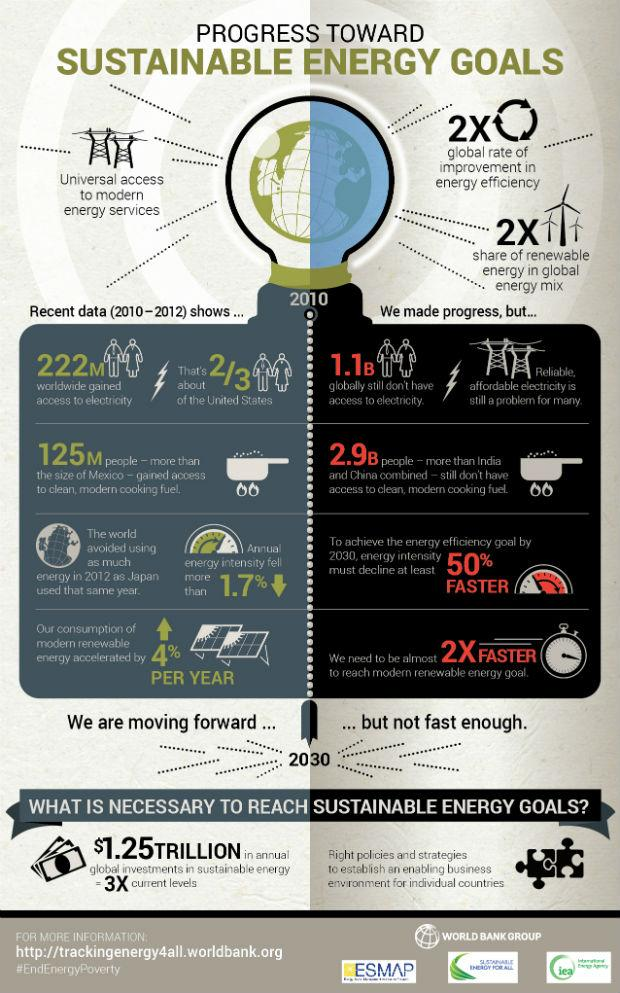Highlight a few significant elements in this photo. The world's population that lacks access to electricity is 1.1 billion. The consumption of modern renewable energy has increased by 4% per year. 